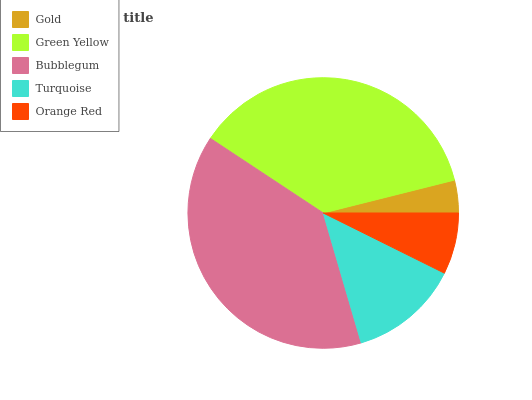Is Gold the minimum?
Answer yes or no. Yes. Is Bubblegum the maximum?
Answer yes or no. Yes. Is Green Yellow the minimum?
Answer yes or no. No. Is Green Yellow the maximum?
Answer yes or no. No. Is Green Yellow greater than Gold?
Answer yes or no. Yes. Is Gold less than Green Yellow?
Answer yes or no. Yes. Is Gold greater than Green Yellow?
Answer yes or no. No. Is Green Yellow less than Gold?
Answer yes or no. No. Is Turquoise the high median?
Answer yes or no. Yes. Is Turquoise the low median?
Answer yes or no. Yes. Is Gold the high median?
Answer yes or no. No. Is Gold the low median?
Answer yes or no. No. 